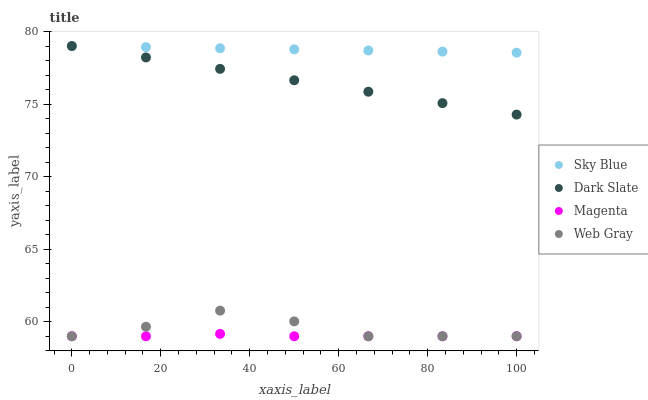Does Magenta have the minimum area under the curve?
Answer yes or no. Yes. Does Sky Blue have the maximum area under the curve?
Answer yes or no. Yes. Does Web Gray have the minimum area under the curve?
Answer yes or no. No. Does Web Gray have the maximum area under the curve?
Answer yes or no. No. Is Sky Blue the smoothest?
Answer yes or no. Yes. Is Web Gray the roughest?
Answer yes or no. Yes. Is Magenta the smoothest?
Answer yes or no. No. Is Magenta the roughest?
Answer yes or no. No. Does Magenta have the lowest value?
Answer yes or no. Yes. Does Dark Slate have the lowest value?
Answer yes or no. No. Does Dark Slate have the highest value?
Answer yes or no. Yes. Does Web Gray have the highest value?
Answer yes or no. No. Is Web Gray less than Sky Blue?
Answer yes or no. Yes. Is Sky Blue greater than Magenta?
Answer yes or no. Yes. Does Magenta intersect Web Gray?
Answer yes or no. Yes. Is Magenta less than Web Gray?
Answer yes or no. No. Is Magenta greater than Web Gray?
Answer yes or no. No. Does Web Gray intersect Sky Blue?
Answer yes or no. No. 